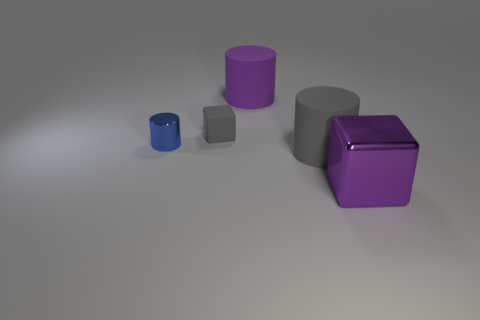What size is the blue thing that is the same shape as the big gray thing?
Your answer should be very brief. Small. Is the number of big purple rubber things that are in front of the shiny cylinder less than the number of small gray matte cubes?
Make the answer very short. Yes. What number of big red metallic blocks are there?
Ensure brevity in your answer.  0. What number of metal cylinders have the same color as the metal block?
Give a very brief answer. 0. Do the purple rubber object and the small blue object have the same shape?
Your answer should be compact. Yes. How big is the purple thing that is on the right side of the big object that is behind the small blue cylinder?
Make the answer very short. Large. Is there a green matte cylinder that has the same size as the purple matte cylinder?
Offer a very short reply. No. There is a cylinder right of the purple rubber object; does it have the same size as the block that is behind the purple metallic thing?
Provide a succinct answer. No. What shape is the metal thing that is on the left side of the block that is on the left side of the purple block?
Provide a succinct answer. Cylinder. There is a gray cube; how many small gray cubes are in front of it?
Provide a short and direct response. 0. 